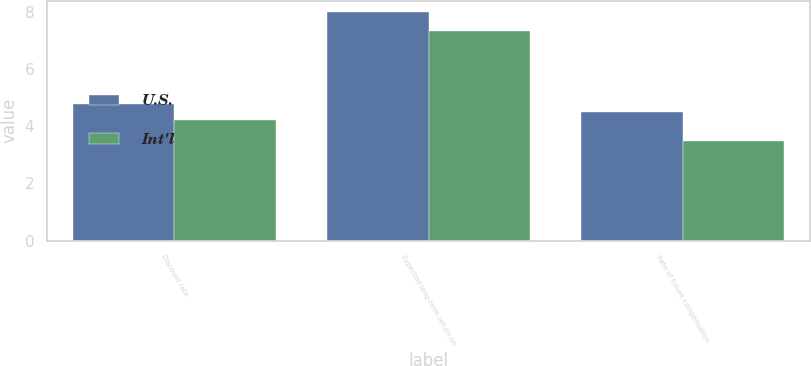<chart> <loc_0><loc_0><loc_500><loc_500><stacked_bar_chart><ecel><fcel>Discount rate<fcel>Expected long-term return on<fcel>Rate of future compensation<nl><fcel>U.S.<fcel>4.79<fcel>8<fcel>4.5<nl><fcel>Int'l<fcel>4.23<fcel>7.33<fcel>3.5<nl></chart> 